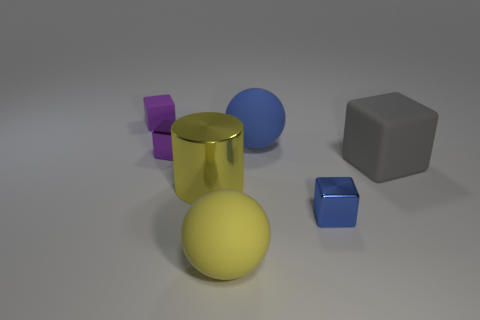Add 1 green metallic blocks. How many objects exist? 8 Subtract all cylinders. How many objects are left? 6 Add 6 tiny blue metal things. How many tiny blue metal things are left? 7 Add 3 small blocks. How many small blocks exist? 6 Subtract 0 cyan cylinders. How many objects are left? 7 Subtract all blue balls. Subtract all big cylinders. How many objects are left? 5 